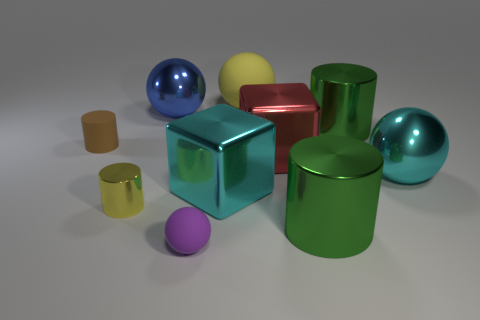Subtract all tiny yellow metallic cylinders. How many cylinders are left? 3 Subtract all balls. How many objects are left? 6 Subtract all large shiny cylinders. Subtract all big green cylinders. How many objects are left? 6 Add 6 small metal cylinders. How many small metal cylinders are left? 7 Add 2 brown matte balls. How many brown matte balls exist? 2 Subtract all green cylinders. How many cylinders are left? 2 Subtract 0 gray cubes. How many objects are left? 10 Subtract 2 cylinders. How many cylinders are left? 2 Subtract all red cylinders. Subtract all yellow cubes. How many cylinders are left? 4 Subtract all gray cylinders. How many gray balls are left? 0 